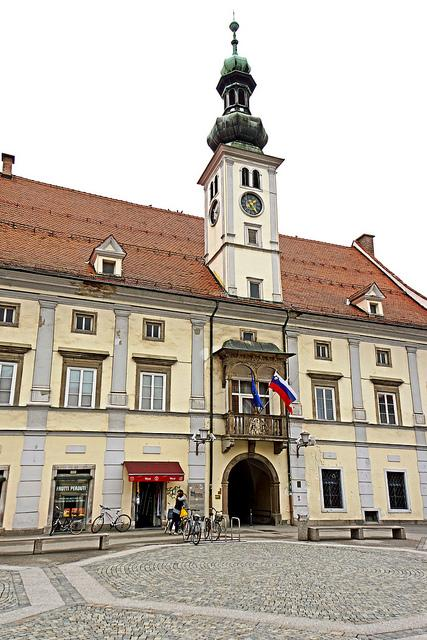What can you use the bike rack for to keep your bike safe? lock 